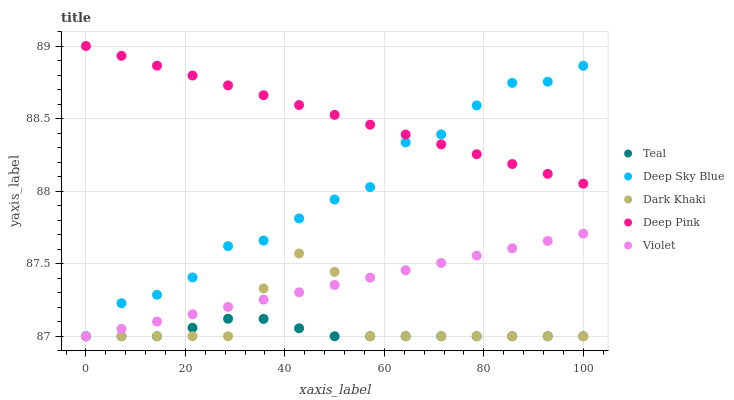Does Teal have the minimum area under the curve?
Answer yes or no. Yes. Does Deep Pink have the maximum area under the curve?
Answer yes or no. Yes. Does Deep Sky Blue have the minimum area under the curve?
Answer yes or no. No. Does Deep Sky Blue have the maximum area under the curve?
Answer yes or no. No. Is Violet the smoothest?
Answer yes or no. Yes. Is Deep Sky Blue the roughest?
Answer yes or no. Yes. Is Deep Pink the smoothest?
Answer yes or no. No. Is Deep Pink the roughest?
Answer yes or no. No. Does Dark Khaki have the lowest value?
Answer yes or no. Yes. Does Deep Pink have the lowest value?
Answer yes or no. No. Does Deep Pink have the highest value?
Answer yes or no. Yes. Does Deep Sky Blue have the highest value?
Answer yes or no. No. Is Teal less than Deep Pink?
Answer yes or no. Yes. Is Deep Pink greater than Dark Khaki?
Answer yes or no. Yes. Does Teal intersect Violet?
Answer yes or no. Yes. Is Teal less than Violet?
Answer yes or no. No. Is Teal greater than Violet?
Answer yes or no. No. Does Teal intersect Deep Pink?
Answer yes or no. No. 